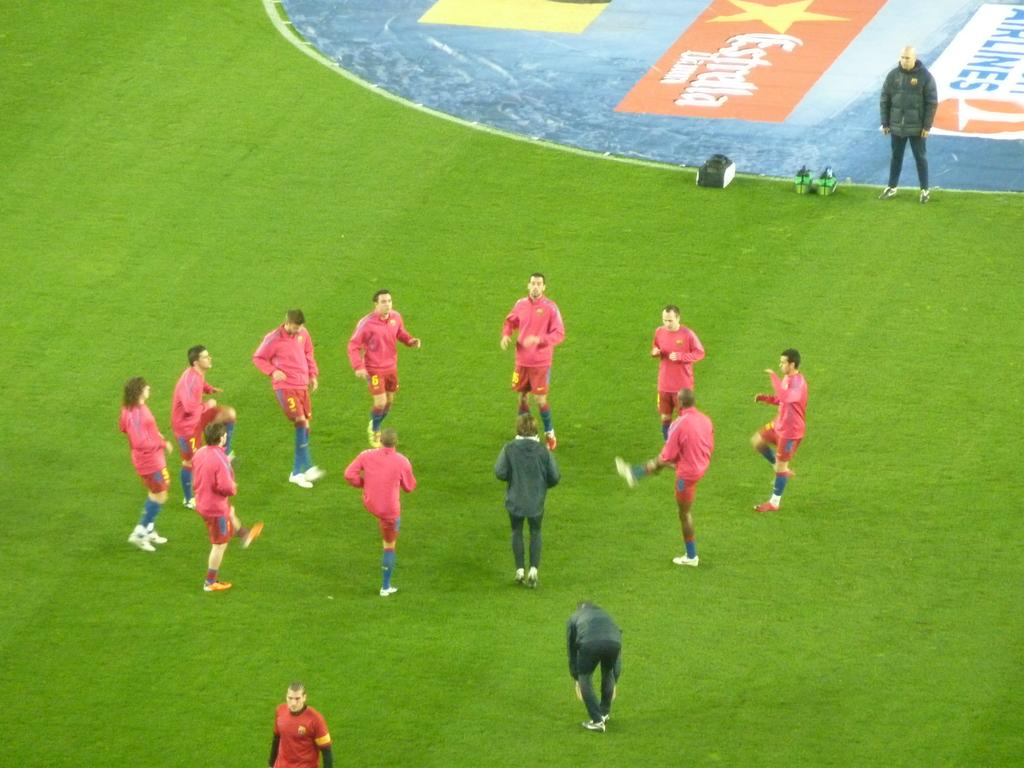<image>
Present a compact description of the photo's key features. A soccer team warming up on the pitch before a match which is partly sponsored by Estrella Damm 